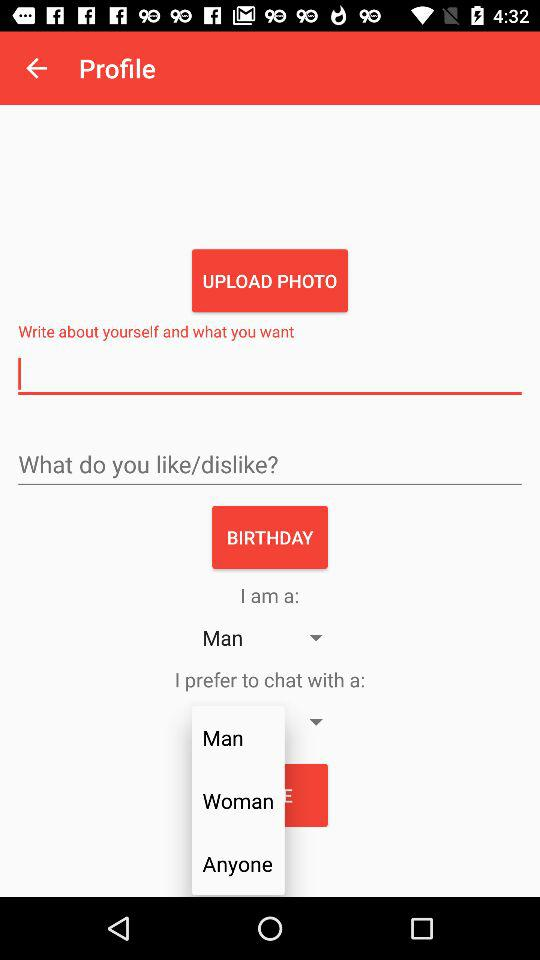With whom does the user prefer to chat?
When the provided information is insufficient, respond with <no answer>. <no answer> 